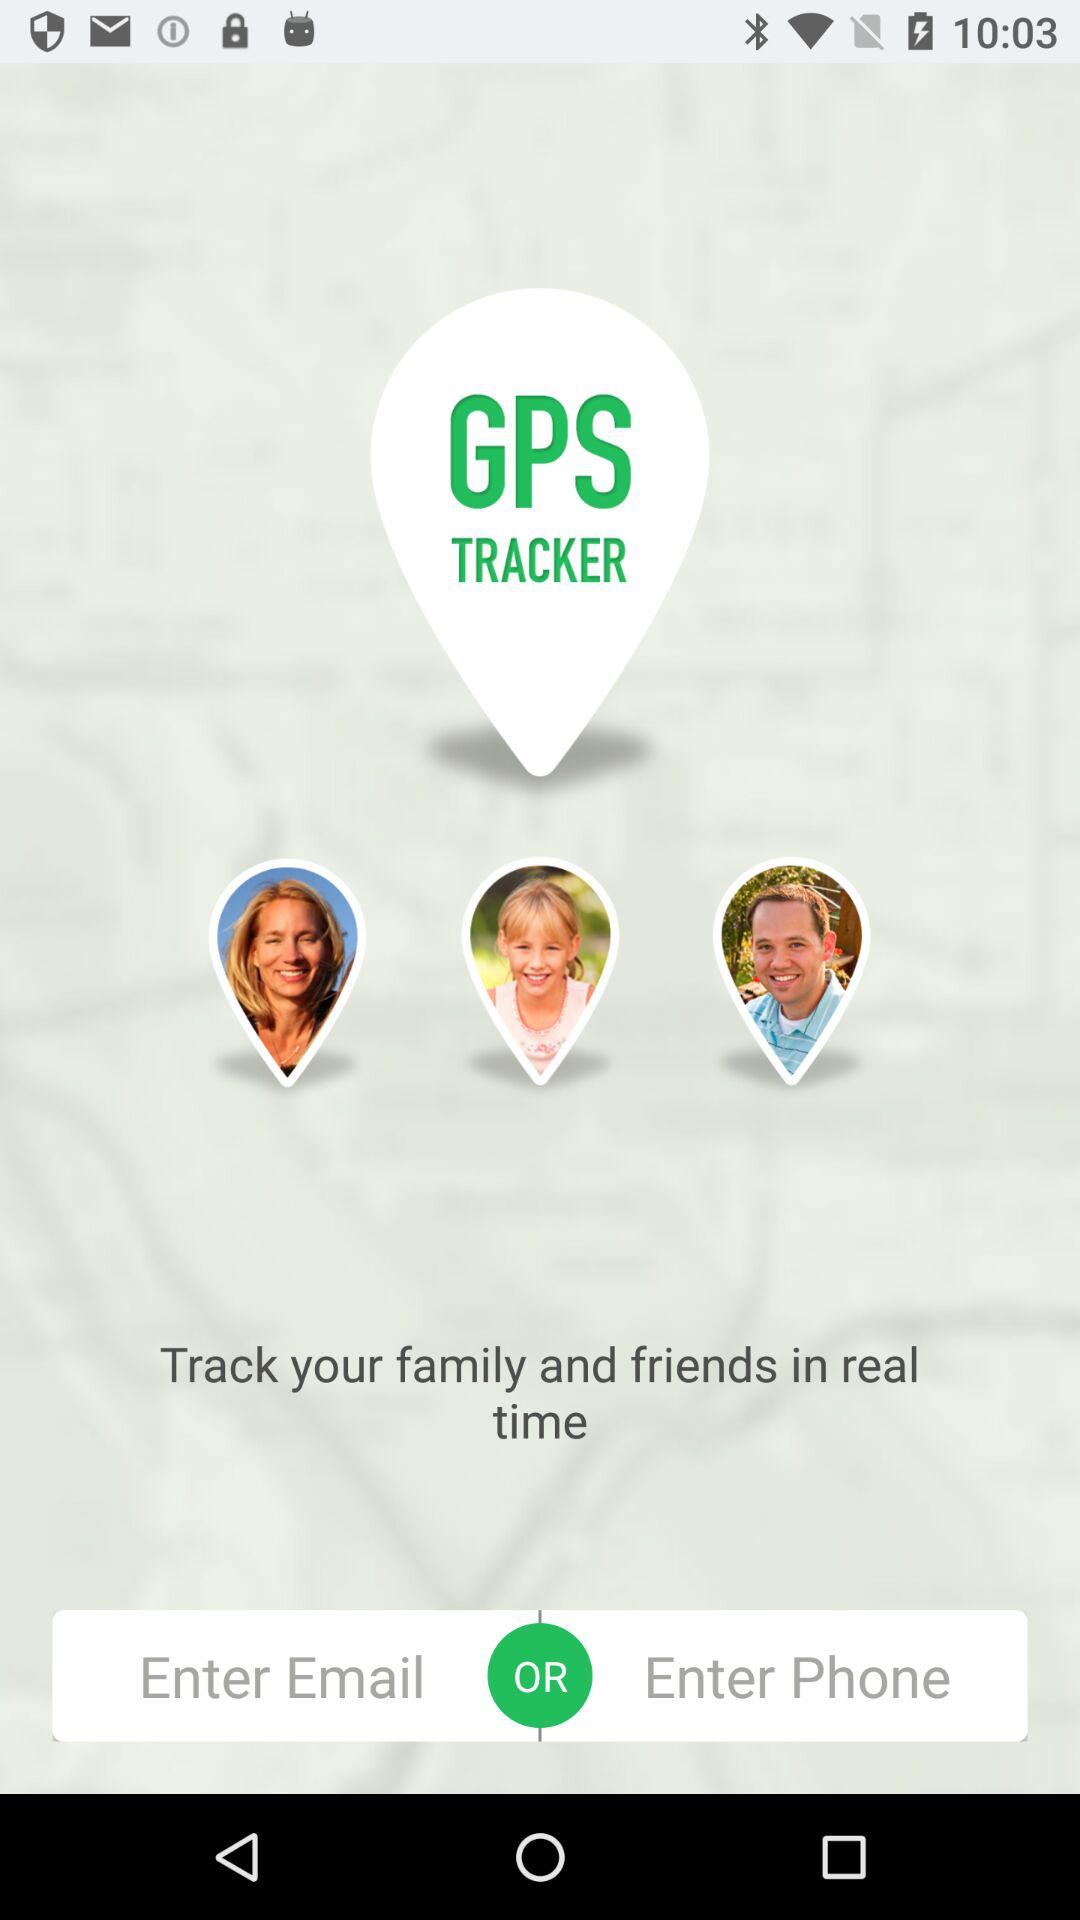What is the app name? The app name is "GPS TRACKER". 